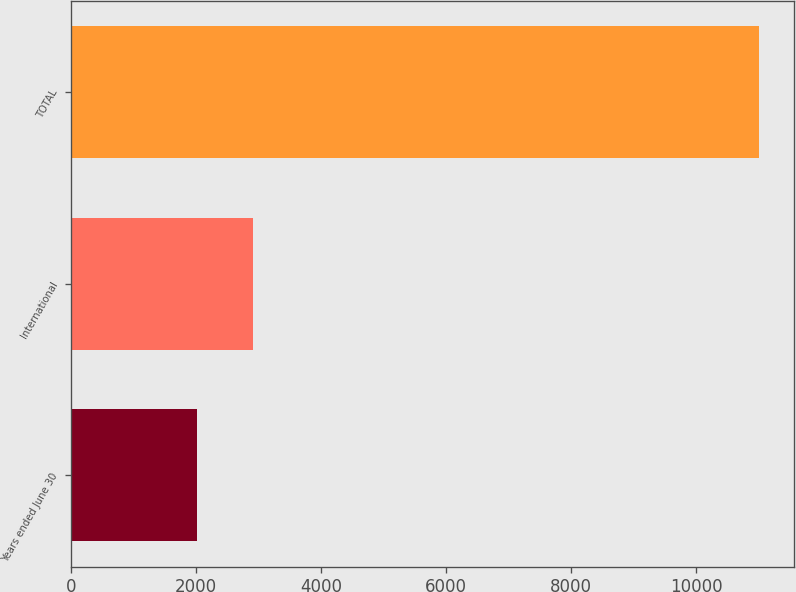Convert chart. <chart><loc_0><loc_0><loc_500><loc_500><bar_chart><fcel>Years ended June 30<fcel>International<fcel>TOTAL<nl><fcel>2015<fcel>2914.7<fcel>11012<nl></chart> 